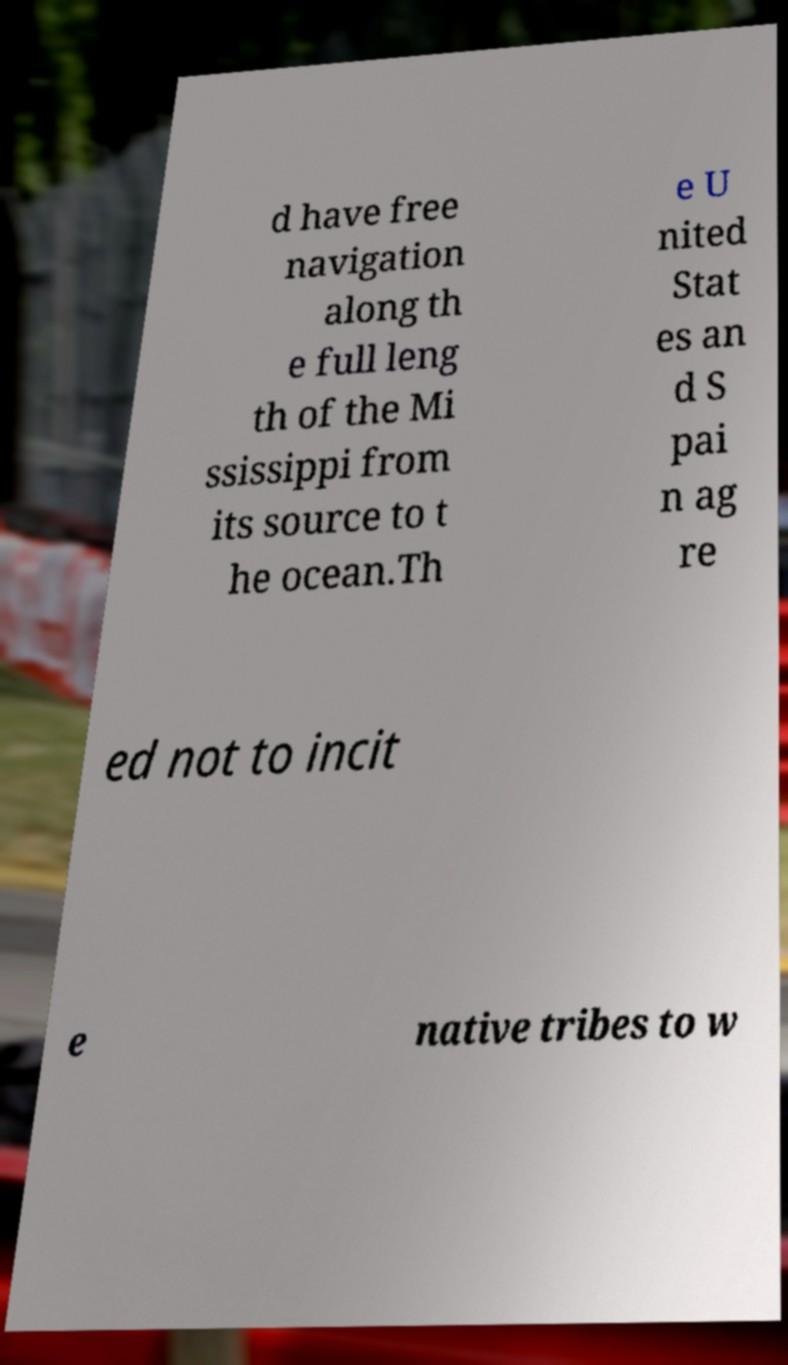What messages or text are displayed in this image? I need them in a readable, typed format. d have free navigation along th e full leng th of the Mi ssissippi from its source to t he ocean.Th e U nited Stat es an d S pai n ag re ed not to incit e native tribes to w 